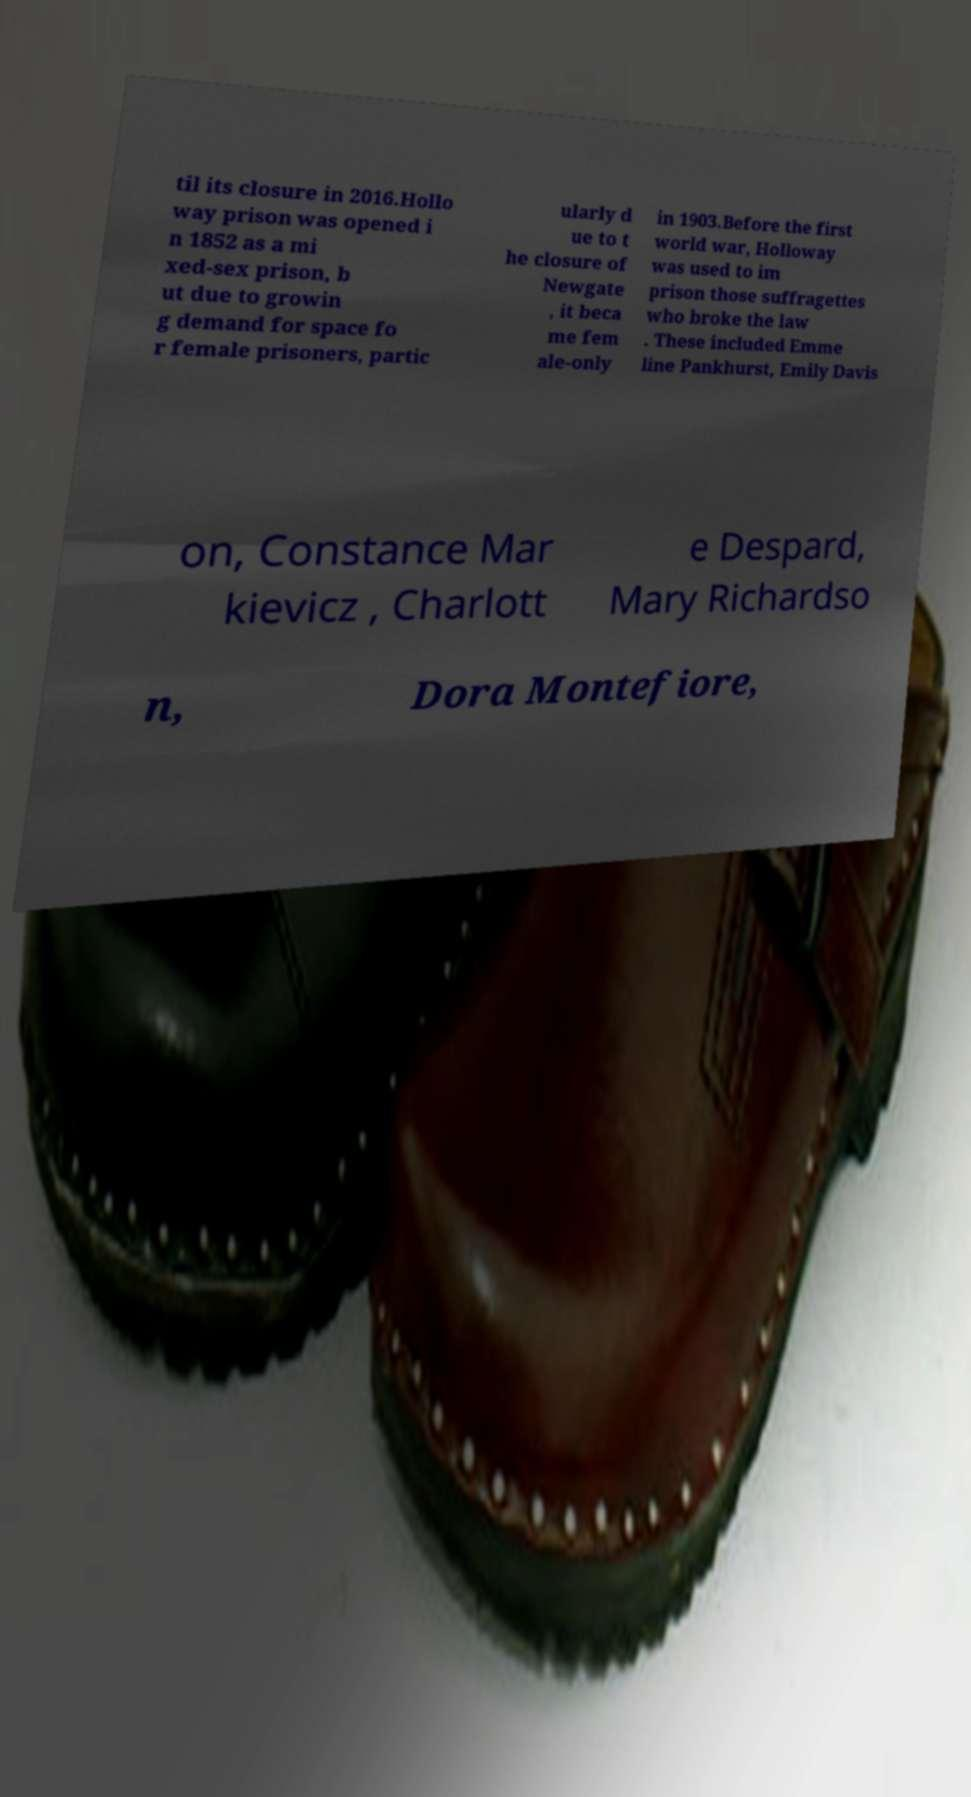Can you read and provide the text displayed in the image?This photo seems to have some interesting text. Can you extract and type it out for me? til its closure in 2016.Hollo way prison was opened i n 1852 as a mi xed-sex prison, b ut due to growin g demand for space fo r female prisoners, partic ularly d ue to t he closure of Newgate , it beca me fem ale-only in 1903.Before the first world war, Holloway was used to im prison those suffragettes who broke the law . These included Emme line Pankhurst, Emily Davis on, Constance Mar kievicz , Charlott e Despard, Mary Richardso n, Dora Montefiore, 